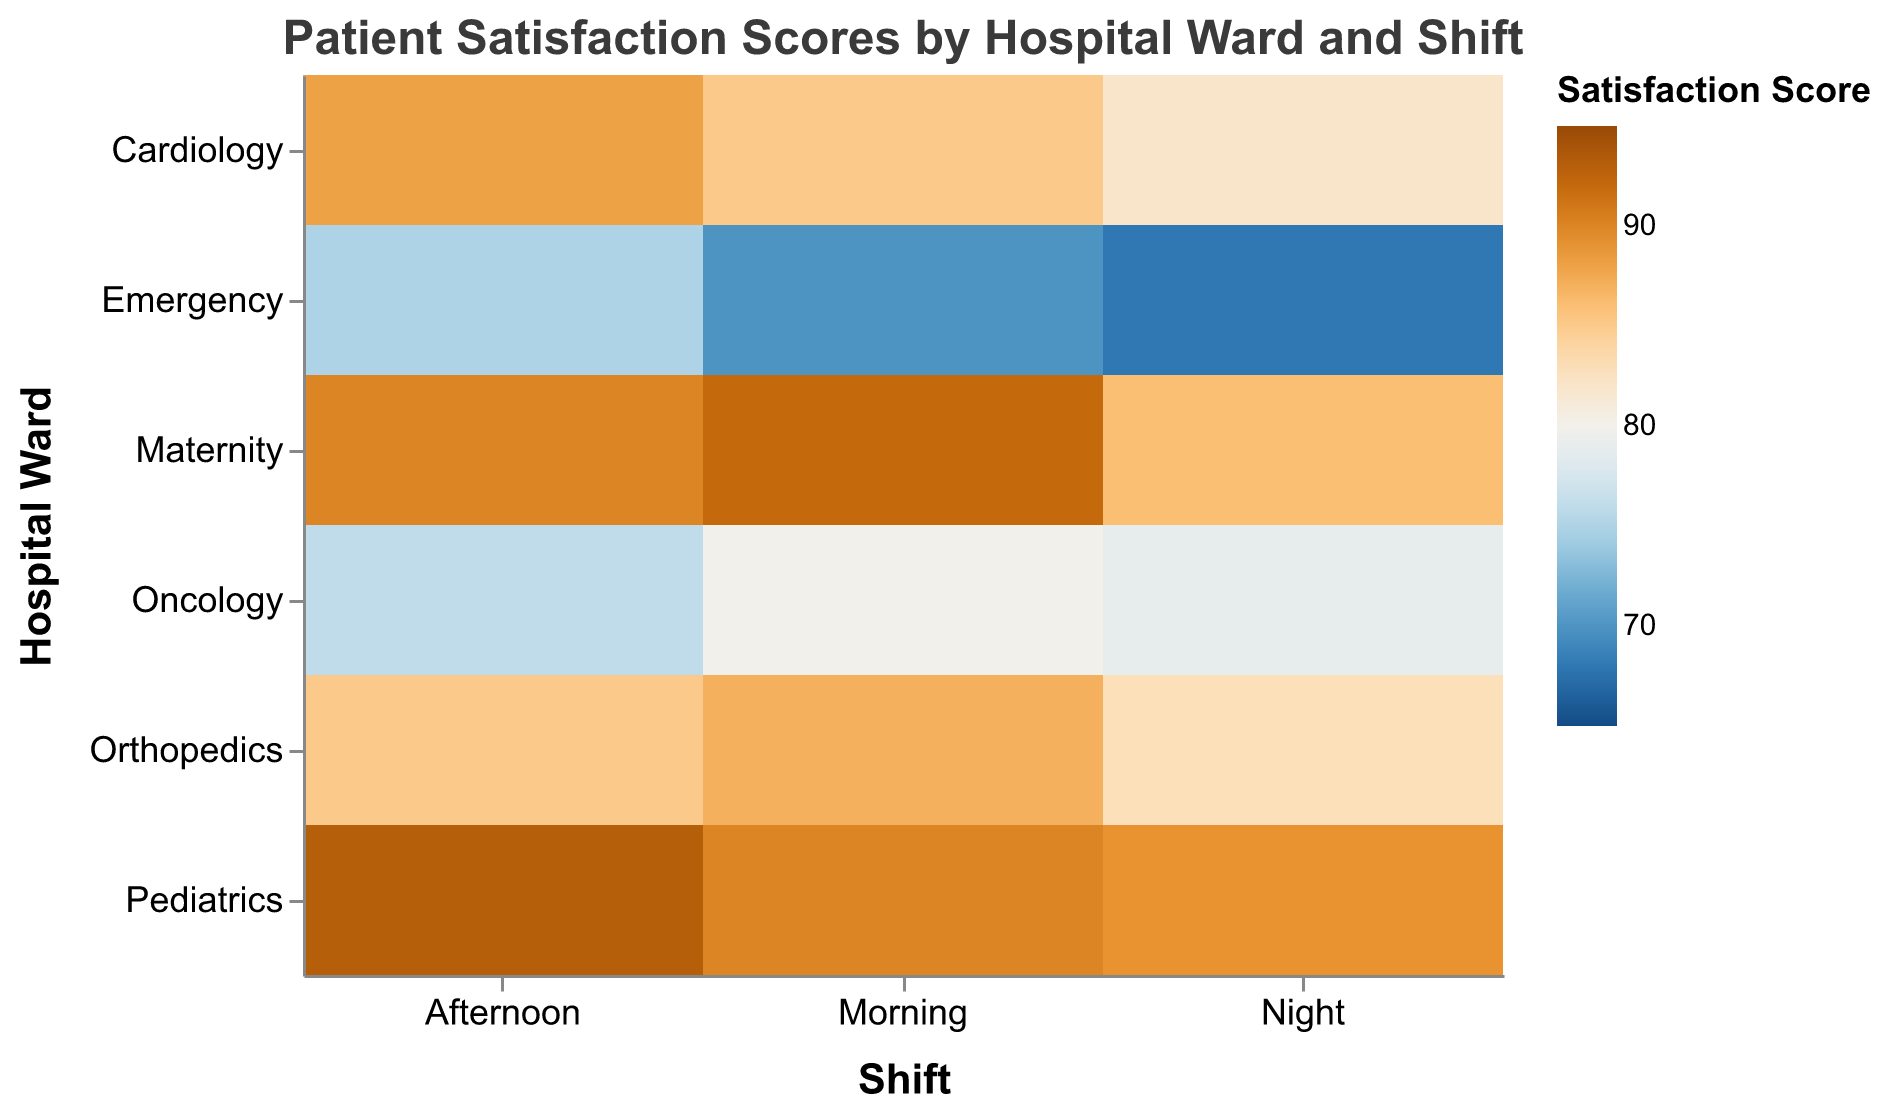What is the title of the figure? The title of the figure is located at the top center and serves as a summary of the data being visualized. Referring to the given code, the title is displayed in bold font.
Answer: Patient Satisfaction Scores by Hospital Ward and Shift Which hospital ward has the highest patient satisfaction score during the Morning shift? Look at the cells under the "Morning" column and identify the one with the highest color intensity. The hover tooltip can confirm the exact score.
Answer: Maternity How does the patient satisfaction for the Oncology ward during the Afternoon compare to Cardiology in the Night shift? Check the color intensity for Oncology in the Afternoon and Cardiology during the Night. The tooltip will show the exact values: Oncology Afternoon is 76, Cardiology Night is 82.
Answer: Oncology Afternoon is lower Which shift generally has the lowest patient satisfaction scores based on color intensity? By scanning the columns, the "Night" shift generally has lower color intensity compared to Morning and Afternoon shifts.
Answer: Night What is the highest patient satisfaction score recorded and in which ward and shift does it occur? Look for the cell with the highest color intensity and check hover tooltip. The highest value listed is 93, occurring in the Pediatrics ward during the Afternoon shift.
Answer: Pediatrics Afternoon Calculate the average patient satisfaction score for the Orthopedics ward across all shifts. The scores for Orthopedics are 87 (Morning), 85 (Afternoon), and 83 (Night). Thus, the average is (87 + 85 + 83) / 3.
Answer: 85 Between Maternity and Emergency wards, which ward has a higher average satisfaction score? Calculate the averages: Maternity (92, 90, 86) average is (92 + 90 + 86) / 3, and Emergency (70, 75, 68) average is (70 + 75 + 68) / 3. Compare the results. Maternity: 89.33, Emergency: 71.
Answer: Maternity What is the general trend in patient satisfaction scores for the Oncology ward across all shifts? Examine the score values for Oncology at Morning (80), Afternoon (76), and Night (79). Notice the initial dip from Morning to Afternoon and a slight increase by Night.
Answer: Decreasing then slightly increasing How does the Morning shift satisfaction score for Cardiology compare to the Morning shift for Emergency? Look at the cells for Cardiology Morning (85) and Emergency Morning (70). Cardiology’s score is higher.
Answer: Cardiology Morning is higher Which ward exhibits the most consistent patient satisfaction scores across different shifts? Analyze the variation in the scores for each ward: smallest range indicates consistency. Orthopedics scores are 87, 85, 83 (range = 4).
Answer: Orthopedics 